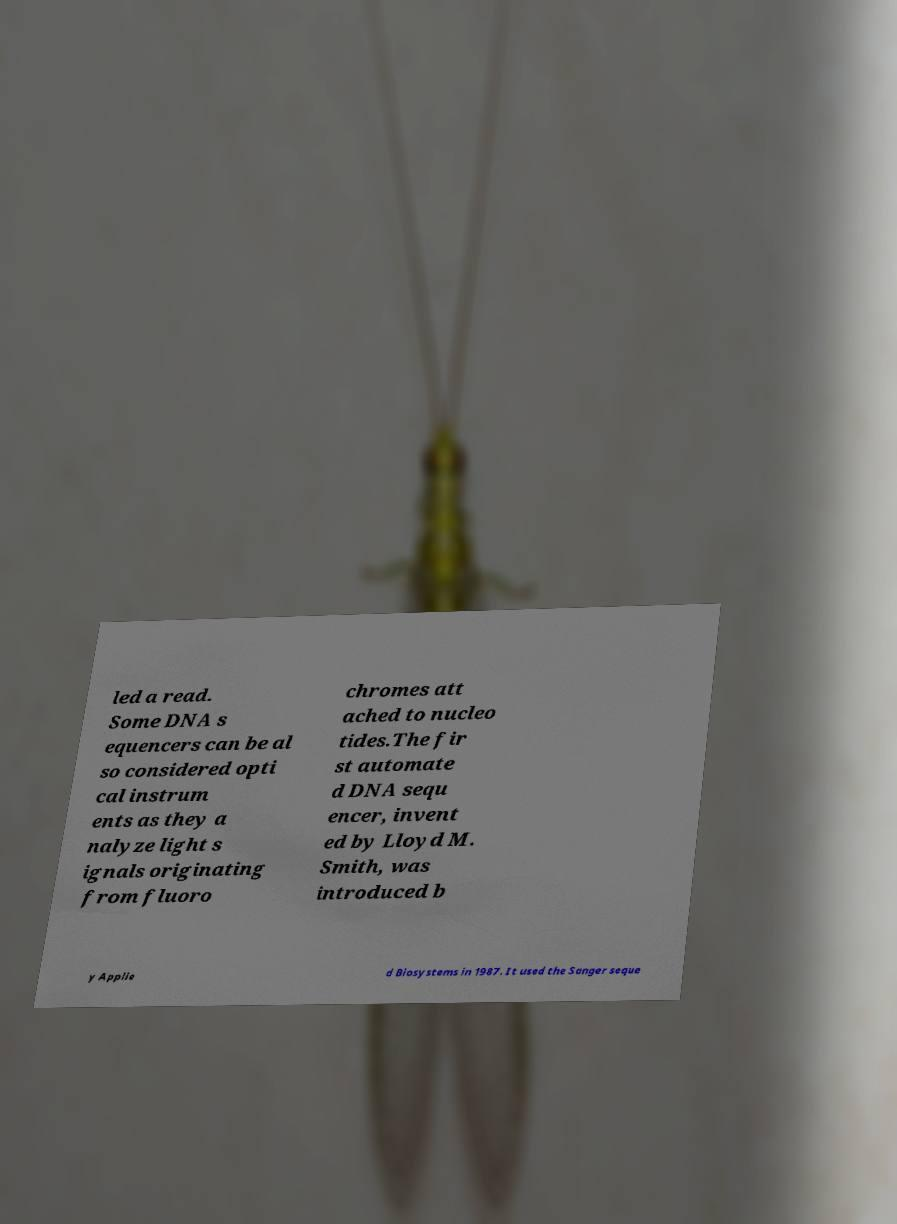Can you accurately transcribe the text from the provided image for me? led a read. Some DNA s equencers can be al so considered opti cal instrum ents as they a nalyze light s ignals originating from fluoro chromes att ached to nucleo tides.The fir st automate d DNA sequ encer, invent ed by Lloyd M. Smith, was introduced b y Applie d Biosystems in 1987. It used the Sanger seque 